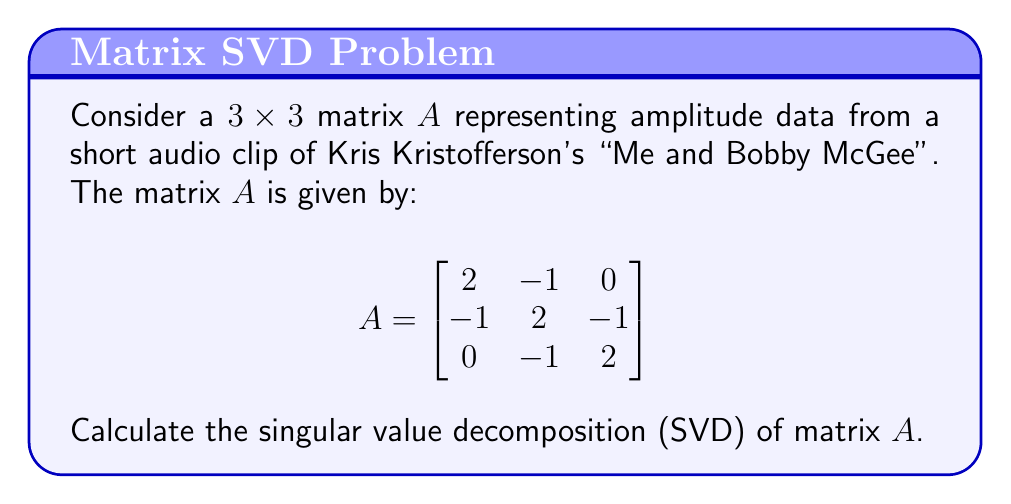Can you solve this math problem? To find the SVD of matrix $A$, we need to determine matrices $U$, $\Sigma$, and $V^T$ such that $A = U\Sigma V^T$. Here's how we proceed:

1) First, calculate $A^TA$ and $AA^T$:

   $$A^TA = AA^T = \begin{bmatrix}
   6 & -4 & 1 \\
   -4 & 6 & -4 \\
   1 & -4 & 6
   \end{bmatrix}$$

2) Find the eigenvalues of $A^TA$ (or $AA^T$):
   Characteristic equation: $\det(A^TA - \lambda I) = 0$
   $(\lambda - 1)(\lambda - 3)(\lambda - 9) = 0$
   Eigenvalues: $\lambda_1 = 9$, $\lambda_2 = 3$, $\lambda_3 = 1$

3) The singular values are the square roots of these eigenvalues:
   $\sigma_1 = 3$, $\sigma_2 = \sqrt{3}$, $\sigma_3 = 1$

4) Construct $\Sigma$:
   $$\Sigma = \begin{bmatrix}
   3 & 0 & 0 \\
   0 & \sqrt{3} & 0 \\
   0 & 0 & 1
   \end{bmatrix}$$

5) Find eigenvectors of $A^TA$ to get columns of $V$:
   For $\lambda_1 = 9$: $v_1 = \frac{1}{\sqrt{6}}[1, 2, 1]^T$
   For $\lambda_2 = 3$: $v_2 = \frac{1}{\sqrt{2}}[1, 0, -1]^T$
   For $\lambda_3 = 1$: $v_3 = \frac{1}{\sqrt{3}}[-1, 1, -1]^T$

6) Construct $V$:
   $$V = \begin{bmatrix}
   \frac{1}{\sqrt{6}} & \frac{1}{\sqrt{2}} & -\frac{1}{\sqrt{3}} \\
   \frac{2}{\sqrt{6}} & 0 & \frac{1}{\sqrt{3}} \\
   \frac{1}{\sqrt{6}} & -\frac{1}{\sqrt{2}} & -\frac{1}{\sqrt{3}}
   \end{bmatrix}$$

7) Calculate $U$ using $U = AV\Sigma^{-1}$:
   $$U = \begin{bmatrix}
   \frac{1}{\sqrt{6}} & \frac{1}{\sqrt{2}} & -\frac{1}{\sqrt{3}} \\
   \frac{2}{\sqrt{6}} & 0 & \frac{1}{\sqrt{3}} \\
   \frac{1}{\sqrt{6}} & -\frac{1}{\sqrt{2}} & -\frac{1}{\sqrt{3}}
   \end{bmatrix}$$

Thus, we have found $U$, $\Sigma$, and $V$ for the SVD of $A$.
Answer: $A = U\Sigma V^T$, where
$U = V = \begin{bmatrix}
\frac{1}{\sqrt{6}} & \frac{1}{\sqrt{2}} & -\frac{1}{\sqrt{3}} \\
\frac{2}{\sqrt{6}} & 0 & \frac{1}{\sqrt{3}} \\
\frac{1}{\sqrt{6}} & -\frac{1}{\sqrt{2}} & -\frac{1}{\sqrt{3}}
\end{bmatrix}$,
$\Sigma = \begin{bmatrix}
3 & 0 & 0 \\
0 & \sqrt{3} & 0 \\
0 & 0 & 1
\end{bmatrix}$ 